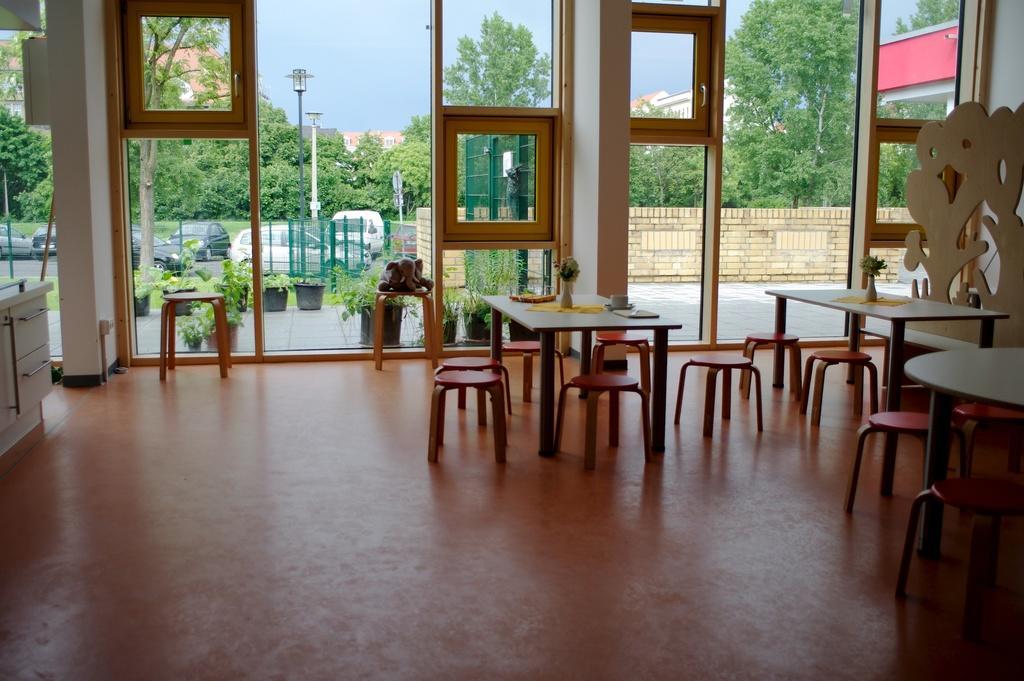Describe this image in one or two sentences. In this image we can see the inside view of the building and there are tables, chairs, cupboard on the floor and there is the structure designed with wood. Outside the building there are potted plants, boards, cars, trees, building, fence, light pole, wall and the sky. 